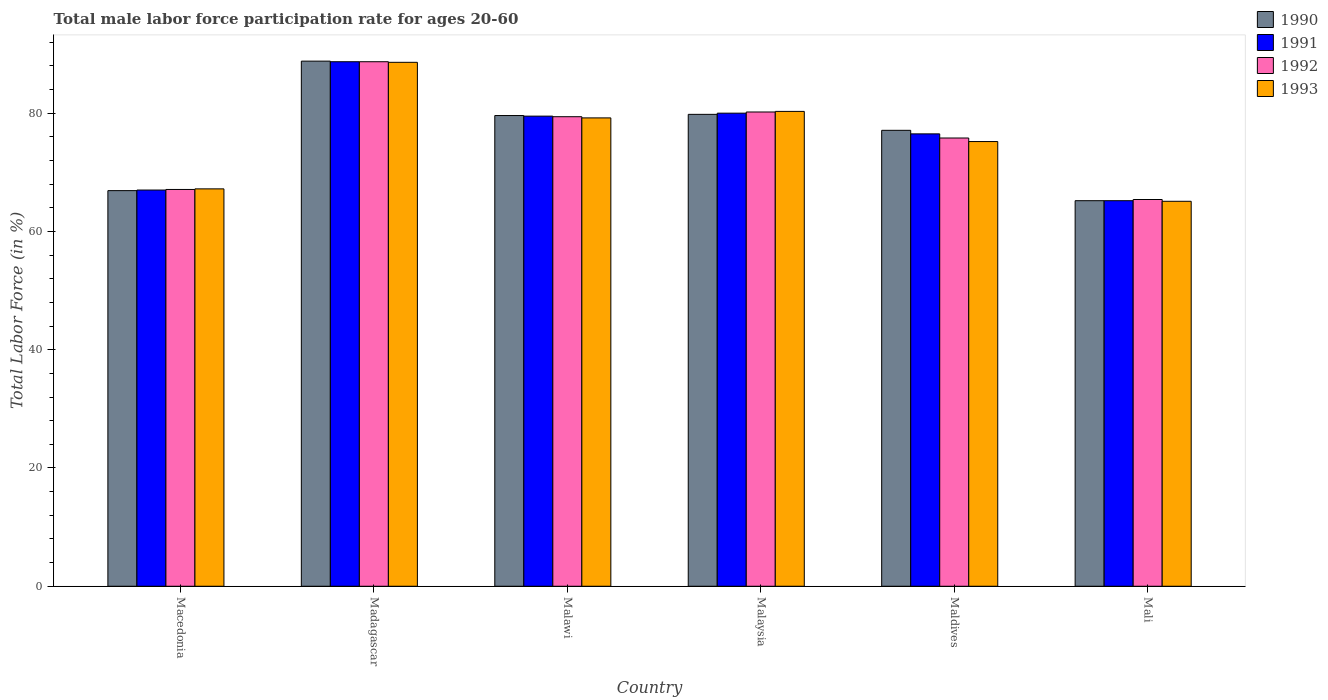How many different coloured bars are there?
Provide a short and direct response. 4. How many groups of bars are there?
Provide a short and direct response. 6. Are the number of bars on each tick of the X-axis equal?
Ensure brevity in your answer.  Yes. How many bars are there on the 5th tick from the left?
Your response must be concise. 4. How many bars are there on the 1st tick from the right?
Ensure brevity in your answer.  4. What is the label of the 3rd group of bars from the left?
Your answer should be very brief. Malawi. What is the male labor force participation rate in 1992 in Malaysia?
Give a very brief answer. 80.2. Across all countries, what is the maximum male labor force participation rate in 1993?
Offer a terse response. 88.6. Across all countries, what is the minimum male labor force participation rate in 1992?
Give a very brief answer. 65.4. In which country was the male labor force participation rate in 1991 maximum?
Keep it short and to the point. Madagascar. In which country was the male labor force participation rate in 1990 minimum?
Offer a very short reply. Mali. What is the total male labor force participation rate in 1993 in the graph?
Your answer should be very brief. 455.6. What is the difference between the male labor force participation rate in 1992 in Malawi and that in Maldives?
Provide a succinct answer. 3.6. What is the difference between the male labor force participation rate in 1991 in Malaysia and the male labor force participation rate in 1992 in Maldives?
Give a very brief answer. 4.2. What is the average male labor force participation rate in 1990 per country?
Your answer should be very brief. 76.23. What is the difference between the male labor force participation rate of/in 1991 and male labor force participation rate of/in 1992 in Malawi?
Keep it short and to the point. 0.1. What is the ratio of the male labor force participation rate in 1993 in Malawi to that in Maldives?
Make the answer very short. 1.05. Is the male labor force participation rate in 1991 in Madagascar less than that in Mali?
Your answer should be compact. No. Is the difference between the male labor force participation rate in 1991 in Maldives and Mali greater than the difference between the male labor force participation rate in 1992 in Maldives and Mali?
Make the answer very short. Yes. What is the difference between the highest and the second highest male labor force participation rate in 1992?
Your answer should be very brief. 8.5. What is the difference between the highest and the lowest male labor force participation rate in 1992?
Offer a terse response. 23.3. In how many countries, is the male labor force participation rate in 1992 greater than the average male labor force participation rate in 1992 taken over all countries?
Provide a short and direct response. 3. Is the sum of the male labor force participation rate in 1990 in Malawi and Malaysia greater than the maximum male labor force participation rate in 1991 across all countries?
Give a very brief answer. Yes. Is it the case that in every country, the sum of the male labor force participation rate in 1993 and male labor force participation rate in 1992 is greater than the sum of male labor force participation rate in 1990 and male labor force participation rate in 1991?
Your response must be concise. No. What does the 2nd bar from the right in Macedonia represents?
Give a very brief answer. 1992. Are all the bars in the graph horizontal?
Provide a short and direct response. No. What is the difference between two consecutive major ticks on the Y-axis?
Keep it short and to the point. 20. Are the values on the major ticks of Y-axis written in scientific E-notation?
Ensure brevity in your answer.  No. How are the legend labels stacked?
Offer a very short reply. Vertical. What is the title of the graph?
Offer a terse response. Total male labor force participation rate for ages 20-60. What is the label or title of the Y-axis?
Offer a very short reply. Total Labor Force (in %). What is the Total Labor Force (in %) in 1990 in Macedonia?
Provide a short and direct response. 66.9. What is the Total Labor Force (in %) in 1992 in Macedonia?
Ensure brevity in your answer.  67.1. What is the Total Labor Force (in %) in 1993 in Macedonia?
Keep it short and to the point. 67.2. What is the Total Labor Force (in %) of 1990 in Madagascar?
Keep it short and to the point. 88.8. What is the Total Labor Force (in %) of 1991 in Madagascar?
Provide a succinct answer. 88.7. What is the Total Labor Force (in %) of 1992 in Madagascar?
Provide a succinct answer. 88.7. What is the Total Labor Force (in %) in 1993 in Madagascar?
Give a very brief answer. 88.6. What is the Total Labor Force (in %) of 1990 in Malawi?
Your response must be concise. 79.6. What is the Total Labor Force (in %) in 1991 in Malawi?
Offer a terse response. 79.5. What is the Total Labor Force (in %) in 1992 in Malawi?
Provide a short and direct response. 79.4. What is the Total Labor Force (in %) in 1993 in Malawi?
Provide a short and direct response. 79.2. What is the Total Labor Force (in %) of 1990 in Malaysia?
Provide a succinct answer. 79.8. What is the Total Labor Force (in %) of 1992 in Malaysia?
Provide a short and direct response. 80.2. What is the Total Labor Force (in %) in 1993 in Malaysia?
Offer a very short reply. 80.3. What is the Total Labor Force (in %) in 1990 in Maldives?
Your response must be concise. 77.1. What is the Total Labor Force (in %) of 1991 in Maldives?
Provide a short and direct response. 76.5. What is the Total Labor Force (in %) of 1992 in Maldives?
Your answer should be compact. 75.8. What is the Total Labor Force (in %) of 1993 in Maldives?
Give a very brief answer. 75.2. What is the Total Labor Force (in %) of 1990 in Mali?
Offer a terse response. 65.2. What is the Total Labor Force (in %) in 1991 in Mali?
Make the answer very short. 65.2. What is the Total Labor Force (in %) in 1992 in Mali?
Offer a terse response. 65.4. What is the Total Labor Force (in %) of 1993 in Mali?
Your response must be concise. 65.1. Across all countries, what is the maximum Total Labor Force (in %) of 1990?
Offer a terse response. 88.8. Across all countries, what is the maximum Total Labor Force (in %) in 1991?
Offer a very short reply. 88.7. Across all countries, what is the maximum Total Labor Force (in %) in 1992?
Your answer should be very brief. 88.7. Across all countries, what is the maximum Total Labor Force (in %) of 1993?
Your answer should be compact. 88.6. Across all countries, what is the minimum Total Labor Force (in %) of 1990?
Your answer should be compact. 65.2. Across all countries, what is the minimum Total Labor Force (in %) of 1991?
Give a very brief answer. 65.2. Across all countries, what is the minimum Total Labor Force (in %) of 1992?
Your response must be concise. 65.4. Across all countries, what is the minimum Total Labor Force (in %) in 1993?
Offer a terse response. 65.1. What is the total Total Labor Force (in %) of 1990 in the graph?
Your response must be concise. 457.4. What is the total Total Labor Force (in %) of 1991 in the graph?
Make the answer very short. 456.9. What is the total Total Labor Force (in %) of 1992 in the graph?
Provide a succinct answer. 456.6. What is the total Total Labor Force (in %) of 1993 in the graph?
Your answer should be very brief. 455.6. What is the difference between the Total Labor Force (in %) of 1990 in Macedonia and that in Madagascar?
Give a very brief answer. -21.9. What is the difference between the Total Labor Force (in %) of 1991 in Macedonia and that in Madagascar?
Offer a very short reply. -21.7. What is the difference between the Total Labor Force (in %) in 1992 in Macedonia and that in Madagascar?
Give a very brief answer. -21.6. What is the difference between the Total Labor Force (in %) in 1993 in Macedonia and that in Madagascar?
Your answer should be compact. -21.4. What is the difference between the Total Labor Force (in %) of 1991 in Macedonia and that in Malawi?
Ensure brevity in your answer.  -12.5. What is the difference between the Total Labor Force (in %) in 1992 in Macedonia and that in Malawi?
Provide a short and direct response. -12.3. What is the difference between the Total Labor Force (in %) in 1991 in Macedonia and that in Malaysia?
Provide a short and direct response. -13. What is the difference between the Total Labor Force (in %) of 1992 in Macedonia and that in Malaysia?
Make the answer very short. -13.1. What is the difference between the Total Labor Force (in %) in 1993 in Macedonia and that in Maldives?
Make the answer very short. -8. What is the difference between the Total Labor Force (in %) of 1990 in Macedonia and that in Mali?
Provide a succinct answer. 1.7. What is the difference between the Total Labor Force (in %) in 1991 in Macedonia and that in Mali?
Provide a short and direct response. 1.8. What is the difference between the Total Labor Force (in %) of 1992 in Macedonia and that in Mali?
Your answer should be compact. 1.7. What is the difference between the Total Labor Force (in %) of 1993 in Macedonia and that in Mali?
Your response must be concise. 2.1. What is the difference between the Total Labor Force (in %) of 1990 in Madagascar and that in Malawi?
Make the answer very short. 9.2. What is the difference between the Total Labor Force (in %) in 1992 in Madagascar and that in Malawi?
Make the answer very short. 9.3. What is the difference between the Total Labor Force (in %) in 1992 in Madagascar and that in Malaysia?
Provide a succinct answer. 8.5. What is the difference between the Total Labor Force (in %) of 1991 in Madagascar and that in Maldives?
Offer a very short reply. 12.2. What is the difference between the Total Labor Force (in %) in 1992 in Madagascar and that in Maldives?
Your response must be concise. 12.9. What is the difference between the Total Labor Force (in %) in 1993 in Madagascar and that in Maldives?
Offer a terse response. 13.4. What is the difference between the Total Labor Force (in %) of 1990 in Madagascar and that in Mali?
Your answer should be compact. 23.6. What is the difference between the Total Labor Force (in %) in 1991 in Madagascar and that in Mali?
Your answer should be very brief. 23.5. What is the difference between the Total Labor Force (in %) of 1992 in Madagascar and that in Mali?
Provide a succinct answer. 23.3. What is the difference between the Total Labor Force (in %) in 1992 in Malawi and that in Malaysia?
Ensure brevity in your answer.  -0.8. What is the difference between the Total Labor Force (in %) in 1993 in Malawi and that in Malaysia?
Your answer should be very brief. -1.1. What is the difference between the Total Labor Force (in %) of 1990 in Malawi and that in Maldives?
Provide a succinct answer. 2.5. What is the difference between the Total Labor Force (in %) of 1991 in Malawi and that in Maldives?
Make the answer very short. 3. What is the difference between the Total Labor Force (in %) in 1991 in Malawi and that in Mali?
Give a very brief answer. 14.3. What is the difference between the Total Labor Force (in %) of 1992 in Malawi and that in Mali?
Offer a very short reply. 14. What is the difference between the Total Labor Force (in %) in 1990 in Malaysia and that in Maldives?
Provide a succinct answer. 2.7. What is the difference between the Total Labor Force (in %) in 1991 in Malaysia and that in Maldives?
Provide a short and direct response. 3.5. What is the difference between the Total Labor Force (in %) of 1992 in Malaysia and that in Maldives?
Make the answer very short. 4.4. What is the difference between the Total Labor Force (in %) in 1990 in Malaysia and that in Mali?
Offer a terse response. 14.6. What is the difference between the Total Labor Force (in %) in 1992 in Malaysia and that in Mali?
Your response must be concise. 14.8. What is the difference between the Total Labor Force (in %) in 1993 in Malaysia and that in Mali?
Ensure brevity in your answer.  15.2. What is the difference between the Total Labor Force (in %) in 1990 in Maldives and that in Mali?
Ensure brevity in your answer.  11.9. What is the difference between the Total Labor Force (in %) of 1990 in Macedonia and the Total Labor Force (in %) of 1991 in Madagascar?
Offer a very short reply. -21.8. What is the difference between the Total Labor Force (in %) of 1990 in Macedonia and the Total Labor Force (in %) of 1992 in Madagascar?
Your response must be concise. -21.8. What is the difference between the Total Labor Force (in %) in 1990 in Macedonia and the Total Labor Force (in %) in 1993 in Madagascar?
Offer a very short reply. -21.7. What is the difference between the Total Labor Force (in %) in 1991 in Macedonia and the Total Labor Force (in %) in 1992 in Madagascar?
Ensure brevity in your answer.  -21.7. What is the difference between the Total Labor Force (in %) in 1991 in Macedonia and the Total Labor Force (in %) in 1993 in Madagascar?
Make the answer very short. -21.6. What is the difference between the Total Labor Force (in %) in 1992 in Macedonia and the Total Labor Force (in %) in 1993 in Madagascar?
Offer a very short reply. -21.5. What is the difference between the Total Labor Force (in %) of 1990 in Macedonia and the Total Labor Force (in %) of 1991 in Malawi?
Your response must be concise. -12.6. What is the difference between the Total Labor Force (in %) in 1991 in Macedonia and the Total Labor Force (in %) in 1992 in Malawi?
Your answer should be very brief. -12.4. What is the difference between the Total Labor Force (in %) in 1992 in Macedonia and the Total Labor Force (in %) in 1993 in Malawi?
Make the answer very short. -12.1. What is the difference between the Total Labor Force (in %) of 1990 in Macedonia and the Total Labor Force (in %) of 1991 in Malaysia?
Give a very brief answer. -13.1. What is the difference between the Total Labor Force (in %) of 1990 in Macedonia and the Total Labor Force (in %) of 1993 in Malaysia?
Give a very brief answer. -13.4. What is the difference between the Total Labor Force (in %) of 1991 in Macedonia and the Total Labor Force (in %) of 1992 in Malaysia?
Offer a terse response. -13.2. What is the difference between the Total Labor Force (in %) in 1991 in Macedonia and the Total Labor Force (in %) in 1993 in Malaysia?
Offer a very short reply. -13.3. What is the difference between the Total Labor Force (in %) of 1992 in Macedonia and the Total Labor Force (in %) of 1993 in Malaysia?
Your answer should be very brief. -13.2. What is the difference between the Total Labor Force (in %) of 1990 in Macedonia and the Total Labor Force (in %) of 1991 in Maldives?
Ensure brevity in your answer.  -9.6. What is the difference between the Total Labor Force (in %) of 1990 in Macedonia and the Total Labor Force (in %) of 1993 in Maldives?
Offer a terse response. -8.3. What is the difference between the Total Labor Force (in %) in 1990 in Macedonia and the Total Labor Force (in %) in 1991 in Mali?
Offer a very short reply. 1.7. What is the difference between the Total Labor Force (in %) in 1990 in Macedonia and the Total Labor Force (in %) in 1993 in Mali?
Your answer should be very brief. 1.8. What is the difference between the Total Labor Force (in %) in 1991 in Macedonia and the Total Labor Force (in %) in 1992 in Mali?
Your answer should be very brief. 1.6. What is the difference between the Total Labor Force (in %) of 1990 in Madagascar and the Total Labor Force (in %) of 1993 in Malawi?
Provide a succinct answer. 9.6. What is the difference between the Total Labor Force (in %) in 1991 in Madagascar and the Total Labor Force (in %) in 1992 in Malawi?
Ensure brevity in your answer.  9.3. What is the difference between the Total Labor Force (in %) in 1991 in Madagascar and the Total Labor Force (in %) in 1993 in Malawi?
Offer a terse response. 9.5. What is the difference between the Total Labor Force (in %) in 1991 in Madagascar and the Total Labor Force (in %) in 1992 in Malaysia?
Offer a terse response. 8.5. What is the difference between the Total Labor Force (in %) in 1992 in Madagascar and the Total Labor Force (in %) in 1993 in Malaysia?
Your response must be concise. 8.4. What is the difference between the Total Labor Force (in %) of 1990 in Madagascar and the Total Labor Force (in %) of 1991 in Maldives?
Provide a short and direct response. 12.3. What is the difference between the Total Labor Force (in %) of 1990 in Madagascar and the Total Labor Force (in %) of 1993 in Maldives?
Keep it short and to the point. 13.6. What is the difference between the Total Labor Force (in %) of 1990 in Madagascar and the Total Labor Force (in %) of 1991 in Mali?
Offer a terse response. 23.6. What is the difference between the Total Labor Force (in %) of 1990 in Madagascar and the Total Labor Force (in %) of 1992 in Mali?
Give a very brief answer. 23.4. What is the difference between the Total Labor Force (in %) of 1990 in Madagascar and the Total Labor Force (in %) of 1993 in Mali?
Provide a short and direct response. 23.7. What is the difference between the Total Labor Force (in %) in 1991 in Madagascar and the Total Labor Force (in %) in 1992 in Mali?
Your answer should be very brief. 23.3. What is the difference between the Total Labor Force (in %) of 1991 in Madagascar and the Total Labor Force (in %) of 1993 in Mali?
Your response must be concise. 23.6. What is the difference between the Total Labor Force (in %) in 1992 in Madagascar and the Total Labor Force (in %) in 1993 in Mali?
Your response must be concise. 23.6. What is the difference between the Total Labor Force (in %) of 1990 in Malawi and the Total Labor Force (in %) of 1991 in Malaysia?
Your answer should be very brief. -0.4. What is the difference between the Total Labor Force (in %) in 1990 in Malawi and the Total Labor Force (in %) in 1992 in Malaysia?
Offer a terse response. -0.6. What is the difference between the Total Labor Force (in %) in 1992 in Malawi and the Total Labor Force (in %) in 1993 in Malaysia?
Your response must be concise. -0.9. What is the difference between the Total Labor Force (in %) in 1990 in Malawi and the Total Labor Force (in %) in 1991 in Maldives?
Give a very brief answer. 3.1. What is the difference between the Total Labor Force (in %) in 1990 in Malawi and the Total Labor Force (in %) in 1992 in Maldives?
Keep it short and to the point. 3.8. What is the difference between the Total Labor Force (in %) of 1990 in Malawi and the Total Labor Force (in %) of 1993 in Maldives?
Your answer should be very brief. 4.4. What is the difference between the Total Labor Force (in %) of 1991 in Malawi and the Total Labor Force (in %) of 1993 in Maldives?
Keep it short and to the point. 4.3. What is the difference between the Total Labor Force (in %) of 1992 in Malawi and the Total Labor Force (in %) of 1993 in Maldives?
Offer a terse response. 4.2. What is the difference between the Total Labor Force (in %) in 1990 in Malawi and the Total Labor Force (in %) in 1991 in Mali?
Make the answer very short. 14.4. What is the difference between the Total Labor Force (in %) in 1990 in Malawi and the Total Labor Force (in %) in 1992 in Mali?
Your answer should be compact. 14.2. What is the difference between the Total Labor Force (in %) of 1992 in Malawi and the Total Labor Force (in %) of 1993 in Mali?
Your answer should be very brief. 14.3. What is the difference between the Total Labor Force (in %) in 1990 in Malaysia and the Total Labor Force (in %) in 1991 in Maldives?
Provide a short and direct response. 3.3. What is the difference between the Total Labor Force (in %) of 1990 in Malaysia and the Total Labor Force (in %) of 1992 in Maldives?
Ensure brevity in your answer.  4. What is the difference between the Total Labor Force (in %) of 1992 in Malaysia and the Total Labor Force (in %) of 1993 in Maldives?
Ensure brevity in your answer.  5. What is the difference between the Total Labor Force (in %) of 1990 in Malaysia and the Total Labor Force (in %) of 1991 in Mali?
Make the answer very short. 14.6. What is the difference between the Total Labor Force (in %) of 1990 in Malaysia and the Total Labor Force (in %) of 1993 in Mali?
Ensure brevity in your answer.  14.7. What is the difference between the Total Labor Force (in %) in 1992 in Malaysia and the Total Labor Force (in %) in 1993 in Mali?
Your response must be concise. 15.1. What is the difference between the Total Labor Force (in %) of 1992 in Maldives and the Total Labor Force (in %) of 1993 in Mali?
Make the answer very short. 10.7. What is the average Total Labor Force (in %) in 1990 per country?
Offer a very short reply. 76.23. What is the average Total Labor Force (in %) of 1991 per country?
Make the answer very short. 76.15. What is the average Total Labor Force (in %) in 1992 per country?
Ensure brevity in your answer.  76.1. What is the average Total Labor Force (in %) of 1993 per country?
Offer a terse response. 75.93. What is the difference between the Total Labor Force (in %) of 1990 and Total Labor Force (in %) of 1991 in Macedonia?
Your answer should be compact. -0.1. What is the difference between the Total Labor Force (in %) of 1990 and Total Labor Force (in %) of 1993 in Macedonia?
Provide a short and direct response. -0.3. What is the difference between the Total Labor Force (in %) of 1991 and Total Labor Force (in %) of 1992 in Macedonia?
Give a very brief answer. -0.1. What is the difference between the Total Labor Force (in %) of 1991 and Total Labor Force (in %) of 1993 in Macedonia?
Provide a short and direct response. -0.2. What is the difference between the Total Labor Force (in %) in 1990 and Total Labor Force (in %) in 1992 in Madagascar?
Provide a short and direct response. 0.1. What is the difference between the Total Labor Force (in %) in 1991 and Total Labor Force (in %) in 1992 in Madagascar?
Make the answer very short. 0. What is the difference between the Total Labor Force (in %) in 1992 and Total Labor Force (in %) in 1993 in Madagascar?
Your response must be concise. 0.1. What is the difference between the Total Labor Force (in %) of 1990 and Total Labor Force (in %) of 1991 in Malawi?
Offer a very short reply. 0.1. What is the difference between the Total Labor Force (in %) in 1990 and Total Labor Force (in %) in 1992 in Malawi?
Provide a succinct answer. 0.2. What is the difference between the Total Labor Force (in %) in 1990 and Total Labor Force (in %) in 1993 in Malawi?
Give a very brief answer. 0.4. What is the difference between the Total Labor Force (in %) in 1991 and Total Labor Force (in %) in 1993 in Malawi?
Ensure brevity in your answer.  0.3. What is the difference between the Total Labor Force (in %) in 1990 and Total Labor Force (in %) in 1992 in Malaysia?
Provide a succinct answer. -0.4. What is the difference between the Total Labor Force (in %) in 1991 and Total Labor Force (in %) in 1993 in Malaysia?
Your answer should be very brief. -0.3. What is the difference between the Total Labor Force (in %) of 1992 and Total Labor Force (in %) of 1993 in Malaysia?
Provide a succinct answer. -0.1. What is the difference between the Total Labor Force (in %) in 1990 and Total Labor Force (in %) in 1991 in Maldives?
Your response must be concise. 0.6. What is the difference between the Total Labor Force (in %) in 1990 and Total Labor Force (in %) in 1992 in Maldives?
Provide a succinct answer. 1.3. What is the difference between the Total Labor Force (in %) of 1991 and Total Labor Force (in %) of 1992 in Maldives?
Ensure brevity in your answer.  0.7. What is the difference between the Total Labor Force (in %) of 1991 and Total Labor Force (in %) of 1993 in Maldives?
Keep it short and to the point. 1.3. What is the difference between the Total Labor Force (in %) of 1990 and Total Labor Force (in %) of 1991 in Mali?
Ensure brevity in your answer.  0. What is the ratio of the Total Labor Force (in %) in 1990 in Macedonia to that in Madagascar?
Your answer should be compact. 0.75. What is the ratio of the Total Labor Force (in %) in 1991 in Macedonia to that in Madagascar?
Provide a succinct answer. 0.76. What is the ratio of the Total Labor Force (in %) of 1992 in Macedonia to that in Madagascar?
Offer a terse response. 0.76. What is the ratio of the Total Labor Force (in %) in 1993 in Macedonia to that in Madagascar?
Give a very brief answer. 0.76. What is the ratio of the Total Labor Force (in %) of 1990 in Macedonia to that in Malawi?
Keep it short and to the point. 0.84. What is the ratio of the Total Labor Force (in %) in 1991 in Macedonia to that in Malawi?
Make the answer very short. 0.84. What is the ratio of the Total Labor Force (in %) of 1992 in Macedonia to that in Malawi?
Your answer should be compact. 0.85. What is the ratio of the Total Labor Force (in %) of 1993 in Macedonia to that in Malawi?
Make the answer very short. 0.85. What is the ratio of the Total Labor Force (in %) in 1990 in Macedonia to that in Malaysia?
Give a very brief answer. 0.84. What is the ratio of the Total Labor Force (in %) in 1991 in Macedonia to that in Malaysia?
Ensure brevity in your answer.  0.84. What is the ratio of the Total Labor Force (in %) in 1992 in Macedonia to that in Malaysia?
Offer a terse response. 0.84. What is the ratio of the Total Labor Force (in %) of 1993 in Macedonia to that in Malaysia?
Keep it short and to the point. 0.84. What is the ratio of the Total Labor Force (in %) in 1990 in Macedonia to that in Maldives?
Provide a succinct answer. 0.87. What is the ratio of the Total Labor Force (in %) in 1991 in Macedonia to that in Maldives?
Your answer should be very brief. 0.88. What is the ratio of the Total Labor Force (in %) of 1992 in Macedonia to that in Maldives?
Keep it short and to the point. 0.89. What is the ratio of the Total Labor Force (in %) of 1993 in Macedonia to that in Maldives?
Provide a succinct answer. 0.89. What is the ratio of the Total Labor Force (in %) of 1990 in Macedonia to that in Mali?
Make the answer very short. 1.03. What is the ratio of the Total Labor Force (in %) of 1991 in Macedonia to that in Mali?
Your answer should be compact. 1.03. What is the ratio of the Total Labor Force (in %) of 1993 in Macedonia to that in Mali?
Offer a terse response. 1.03. What is the ratio of the Total Labor Force (in %) of 1990 in Madagascar to that in Malawi?
Your answer should be very brief. 1.12. What is the ratio of the Total Labor Force (in %) in 1991 in Madagascar to that in Malawi?
Make the answer very short. 1.12. What is the ratio of the Total Labor Force (in %) in 1992 in Madagascar to that in Malawi?
Make the answer very short. 1.12. What is the ratio of the Total Labor Force (in %) in 1993 in Madagascar to that in Malawi?
Make the answer very short. 1.12. What is the ratio of the Total Labor Force (in %) in 1990 in Madagascar to that in Malaysia?
Offer a terse response. 1.11. What is the ratio of the Total Labor Force (in %) of 1991 in Madagascar to that in Malaysia?
Offer a terse response. 1.11. What is the ratio of the Total Labor Force (in %) of 1992 in Madagascar to that in Malaysia?
Make the answer very short. 1.11. What is the ratio of the Total Labor Force (in %) of 1993 in Madagascar to that in Malaysia?
Offer a terse response. 1.1. What is the ratio of the Total Labor Force (in %) in 1990 in Madagascar to that in Maldives?
Provide a short and direct response. 1.15. What is the ratio of the Total Labor Force (in %) of 1991 in Madagascar to that in Maldives?
Your answer should be very brief. 1.16. What is the ratio of the Total Labor Force (in %) of 1992 in Madagascar to that in Maldives?
Keep it short and to the point. 1.17. What is the ratio of the Total Labor Force (in %) in 1993 in Madagascar to that in Maldives?
Provide a short and direct response. 1.18. What is the ratio of the Total Labor Force (in %) of 1990 in Madagascar to that in Mali?
Your answer should be very brief. 1.36. What is the ratio of the Total Labor Force (in %) in 1991 in Madagascar to that in Mali?
Offer a very short reply. 1.36. What is the ratio of the Total Labor Force (in %) of 1992 in Madagascar to that in Mali?
Give a very brief answer. 1.36. What is the ratio of the Total Labor Force (in %) of 1993 in Madagascar to that in Mali?
Provide a short and direct response. 1.36. What is the ratio of the Total Labor Force (in %) of 1991 in Malawi to that in Malaysia?
Make the answer very short. 0.99. What is the ratio of the Total Labor Force (in %) in 1992 in Malawi to that in Malaysia?
Provide a short and direct response. 0.99. What is the ratio of the Total Labor Force (in %) in 1993 in Malawi to that in Malaysia?
Your answer should be very brief. 0.99. What is the ratio of the Total Labor Force (in %) in 1990 in Malawi to that in Maldives?
Provide a succinct answer. 1.03. What is the ratio of the Total Labor Force (in %) in 1991 in Malawi to that in Maldives?
Provide a succinct answer. 1.04. What is the ratio of the Total Labor Force (in %) of 1992 in Malawi to that in Maldives?
Ensure brevity in your answer.  1.05. What is the ratio of the Total Labor Force (in %) in 1993 in Malawi to that in Maldives?
Your answer should be very brief. 1.05. What is the ratio of the Total Labor Force (in %) of 1990 in Malawi to that in Mali?
Provide a short and direct response. 1.22. What is the ratio of the Total Labor Force (in %) of 1991 in Malawi to that in Mali?
Ensure brevity in your answer.  1.22. What is the ratio of the Total Labor Force (in %) in 1992 in Malawi to that in Mali?
Your answer should be compact. 1.21. What is the ratio of the Total Labor Force (in %) in 1993 in Malawi to that in Mali?
Give a very brief answer. 1.22. What is the ratio of the Total Labor Force (in %) in 1990 in Malaysia to that in Maldives?
Give a very brief answer. 1.03. What is the ratio of the Total Labor Force (in %) of 1991 in Malaysia to that in Maldives?
Provide a succinct answer. 1.05. What is the ratio of the Total Labor Force (in %) in 1992 in Malaysia to that in Maldives?
Offer a terse response. 1.06. What is the ratio of the Total Labor Force (in %) of 1993 in Malaysia to that in Maldives?
Provide a short and direct response. 1.07. What is the ratio of the Total Labor Force (in %) in 1990 in Malaysia to that in Mali?
Give a very brief answer. 1.22. What is the ratio of the Total Labor Force (in %) of 1991 in Malaysia to that in Mali?
Keep it short and to the point. 1.23. What is the ratio of the Total Labor Force (in %) in 1992 in Malaysia to that in Mali?
Ensure brevity in your answer.  1.23. What is the ratio of the Total Labor Force (in %) of 1993 in Malaysia to that in Mali?
Ensure brevity in your answer.  1.23. What is the ratio of the Total Labor Force (in %) of 1990 in Maldives to that in Mali?
Offer a terse response. 1.18. What is the ratio of the Total Labor Force (in %) in 1991 in Maldives to that in Mali?
Your response must be concise. 1.17. What is the ratio of the Total Labor Force (in %) of 1992 in Maldives to that in Mali?
Your response must be concise. 1.16. What is the ratio of the Total Labor Force (in %) of 1993 in Maldives to that in Mali?
Provide a short and direct response. 1.16. What is the difference between the highest and the second highest Total Labor Force (in %) of 1990?
Your answer should be compact. 9. What is the difference between the highest and the second highest Total Labor Force (in %) of 1993?
Offer a terse response. 8.3. What is the difference between the highest and the lowest Total Labor Force (in %) in 1990?
Give a very brief answer. 23.6. What is the difference between the highest and the lowest Total Labor Force (in %) in 1992?
Provide a succinct answer. 23.3. 